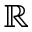Convert formula to latex. <formula><loc_0><loc_0><loc_500><loc_500>\mathbb { R }</formula> 